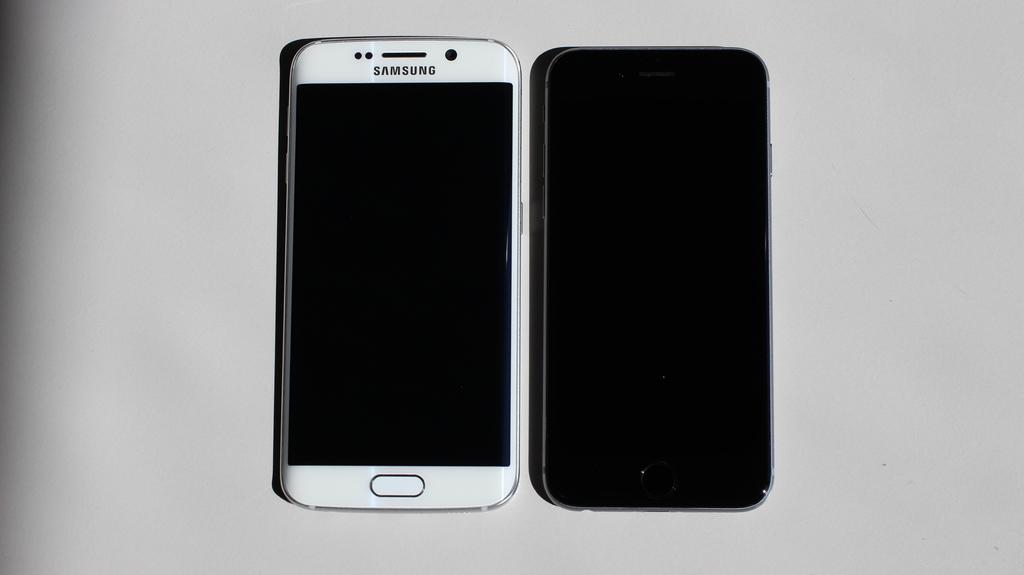<image>
Summarize the visual content of the image. A white Samsung phone is to the left of an all black phone. 